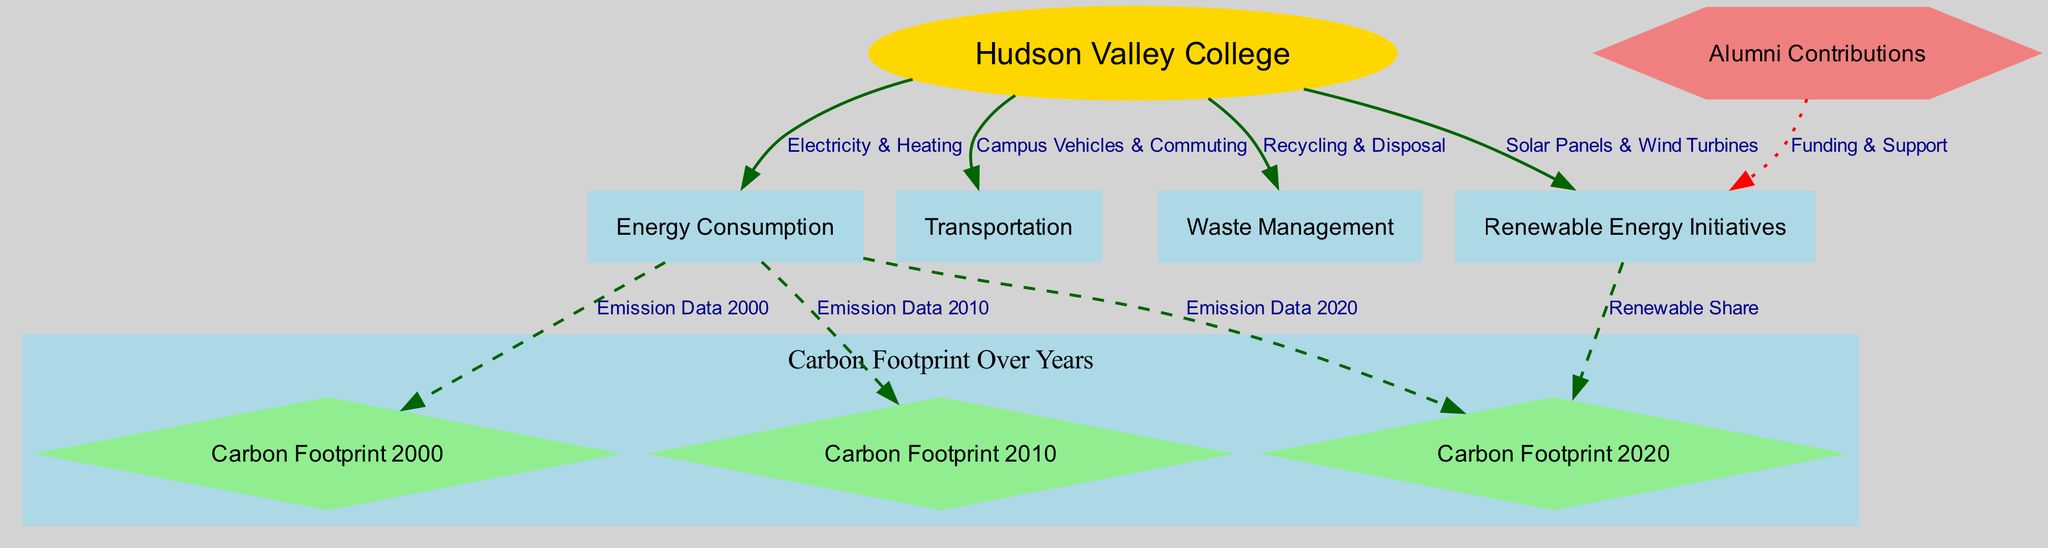What is the main entity represented in the diagram? The main entity is labeled "Hudson Valley College," which serves as the central point from which all other nodes derive or connect.
Answer: Hudson Valley College How many total nodes are present in the diagram? By counting the unique entities represented in the diagram (including Hudson Valley College and various aspects like Energy Consumption, Carbon Footprints, etc.), there are nine nodes in total.
Answer: 9 What type of initiatives are indicated as connected to Hudson Valley College? The diagram shows "Renewable Energy Initiatives" as connected to Hudson Valley College, highlighting its efforts in sustainability.
Answer: Renewable Energy Initiatives Which year has the highest carbon footprint according to the diagram? The carbon footprints for the years are differentiated by the nodes labeled "Carbon Footprint 2000," "Carbon Footprint 2010," and "Carbon Footprint 2020." The diagram structure suggests that as indicated, "Carbon Footprint 2000" being earlier would generally represent a higher value than later years; however, exact values would need to be referenced explicitly.
Answer: Carbon Footprint 2000 What is the relationship between Energy Consumption and the Carbon Footprint 2020? The edge labeled "Emission Data 2020" illustrates a direct relationship, indicating that Energy Consumption directly contributes to the carbon emissions for that year.
Answer: Emission Data 2020 How are Alumni Contributions associated with Renewable Energy Initiatives? The edge titled "Funding & Support" connects "Alumni Contributions" to "Renewable Energy Initiatives," showing that alumni support financial or resource initiatives aimed at renewable energy projects.
Answer: Funding & Support What does the shape of the node for Hudson Valley College signify? The node representing Hudson Valley College is shaped like an ellipse, indicating its primary or central status in the diagram as the main focus of the analysis.
Answer: Ellipse Which connection is represented by a dotted line in the diagram? The connection that is shown with a dotted line is from "Alumni Contributions" to "Renewable Energy Initiatives," implying a supportive or non-directly operational role by alumni.
Answer: Funding & Support How does the diagram visually cluster the carbon footprint data? The diagram visually clusters the carbon footprint data under the subgraph labeled "Carbon Footprint Over Years," grouping the relevant nodes for a clear representation of emission data across specified years.
Answer: Carbon Footprint Over Years 